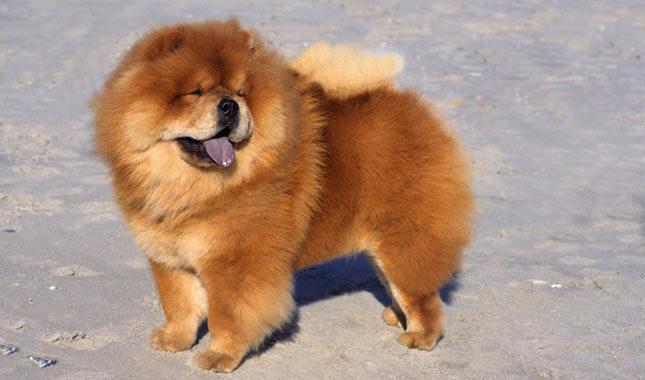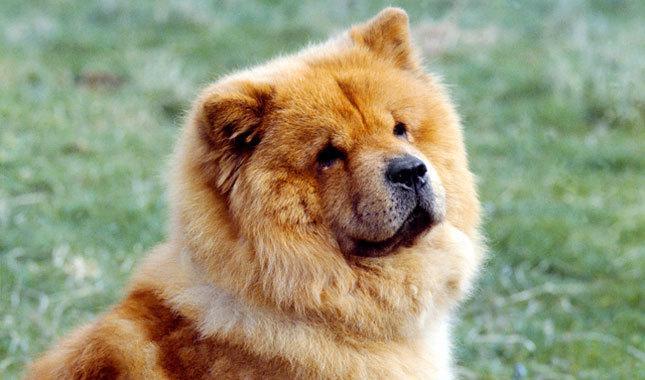The first image is the image on the left, the second image is the image on the right. Evaluate the accuracy of this statement regarding the images: "The dog in the image on the right is in the grass.". Is it true? Answer yes or no. Yes. 